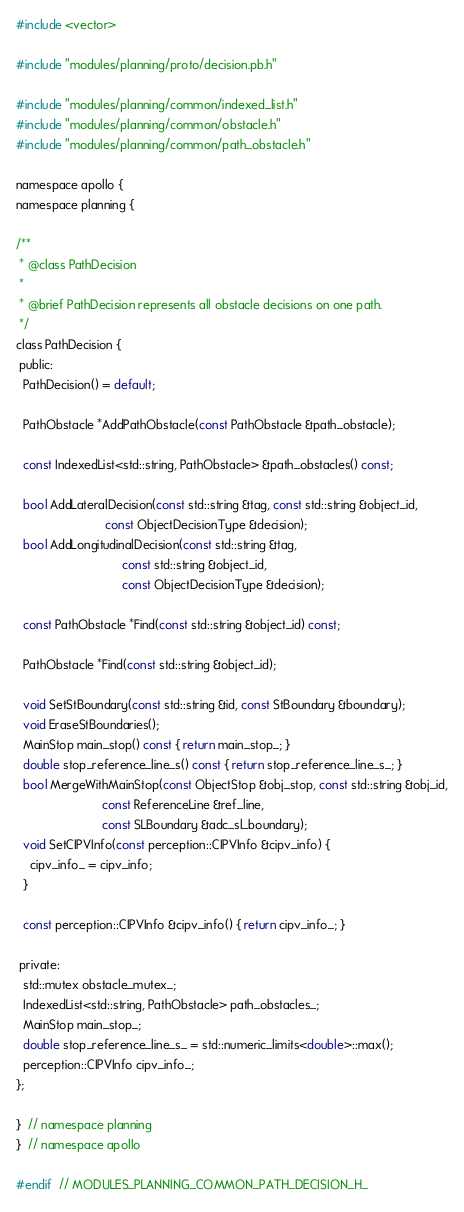Convert code to text. <code><loc_0><loc_0><loc_500><loc_500><_C_>#include <vector>

#include "modules/planning/proto/decision.pb.h"

#include "modules/planning/common/indexed_list.h"
#include "modules/planning/common/obstacle.h"
#include "modules/planning/common/path_obstacle.h"

namespace apollo {
namespace planning {

/**
 * @class PathDecision
 *
 * @brief PathDecision represents all obstacle decisions on one path.
 */
class PathDecision {
 public:
  PathDecision() = default;

  PathObstacle *AddPathObstacle(const PathObstacle &path_obstacle);

  const IndexedList<std::string, PathObstacle> &path_obstacles() const;

  bool AddLateralDecision(const std::string &tag, const std::string &object_id,
                          const ObjectDecisionType &decision);
  bool AddLongitudinalDecision(const std::string &tag,
                               const std::string &object_id,
                               const ObjectDecisionType &decision);

  const PathObstacle *Find(const std::string &object_id) const;

  PathObstacle *Find(const std::string &object_id);

  void SetStBoundary(const std::string &id, const StBoundary &boundary);
  void EraseStBoundaries();
  MainStop main_stop() const { return main_stop_; }
  double stop_reference_line_s() const { return stop_reference_line_s_; }
  bool MergeWithMainStop(const ObjectStop &obj_stop, const std::string &obj_id,
                         const ReferenceLine &ref_line,
                         const SLBoundary &adc_sl_boundary);
  void SetCIPVInfo(const perception::CIPVInfo &cipv_info) {
    cipv_info_ = cipv_info;
  }

  const perception::CIPVInfo &cipv_info() { return cipv_info_; }

 private:
  std::mutex obstacle_mutex_;
  IndexedList<std::string, PathObstacle> path_obstacles_;
  MainStop main_stop_;
  double stop_reference_line_s_ = std::numeric_limits<double>::max();
  perception::CIPVInfo cipv_info_;
};

}  // namespace planning
}  // namespace apollo

#endif  // MODULES_PLANNING_COMMON_PATH_DECISION_H_
</code> 